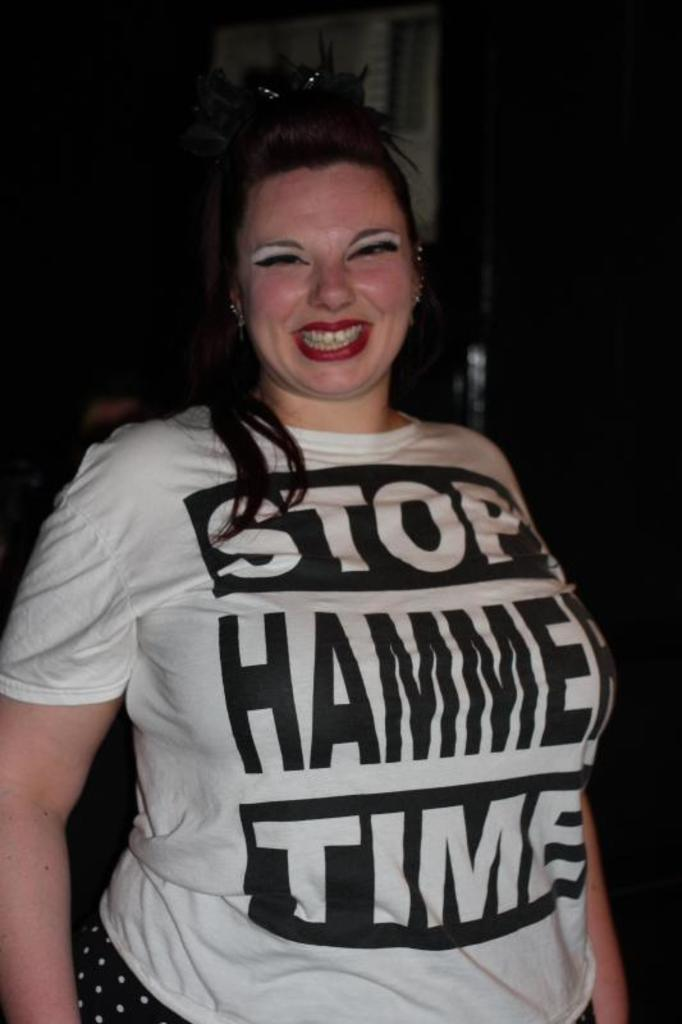<image>
Provide a brief description of the given image. Woman wearing a white shirt that says "STOP HAMMER TIME". 